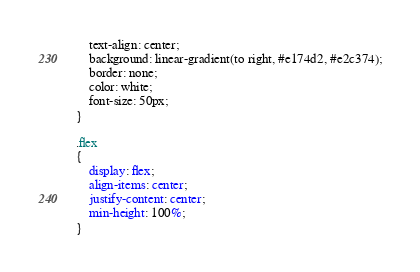Convert code to text. <code><loc_0><loc_0><loc_500><loc_500><_CSS_>    text-align: center;
    background: linear-gradient(to right, #e174d2, #e2c374);
    border: none;
    color: white;
    font-size: 50px;
}

.flex
{
    display: flex;
    align-items: center;
    justify-content: center;
    min-height: 100%;
}

</code> 